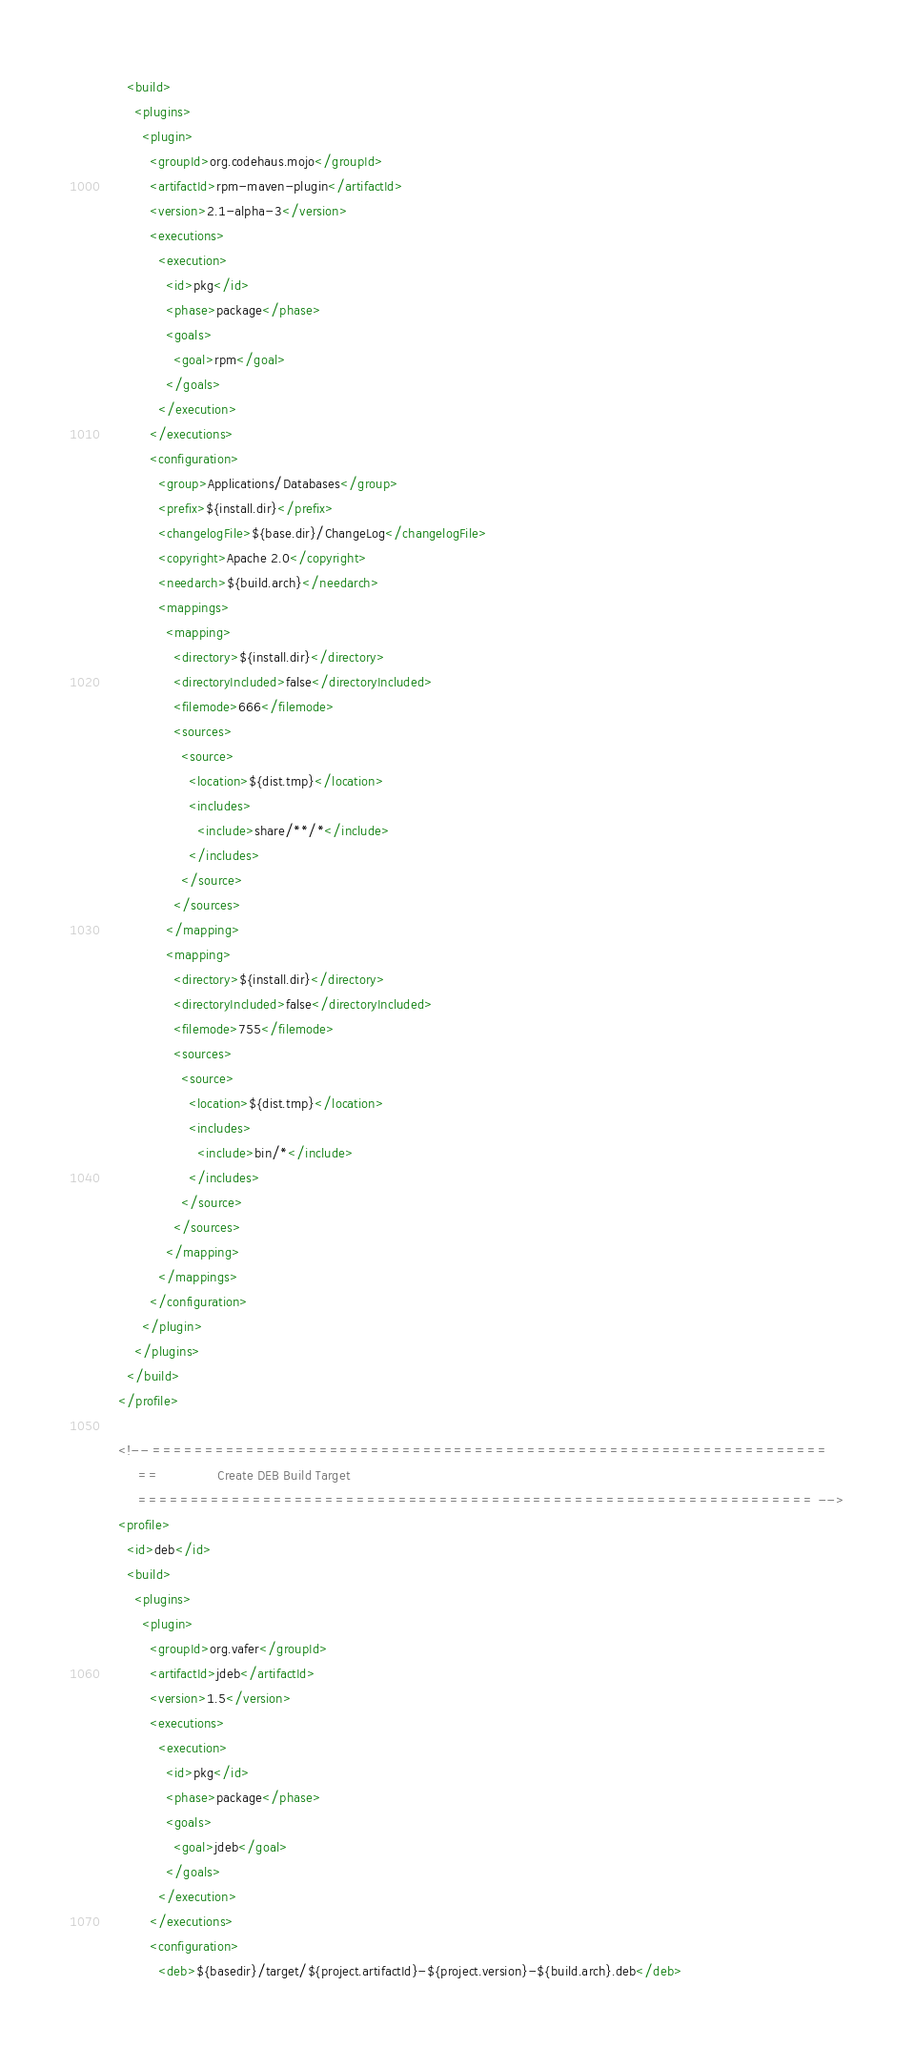<code> <loc_0><loc_0><loc_500><loc_500><_XML_>      <build>
        <plugins>
          <plugin>
            <groupId>org.codehaus.mojo</groupId>
            <artifactId>rpm-maven-plugin</artifactId>
            <version>2.1-alpha-3</version>
            <executions>
              <execution>
                <id>pkg</id>
                <phase>package</phase>
                <goals>
                  <goal>rpm</goal>
                </goals>
              </execution>
            </executions>
            <configuration>
              <group>Applications/Databases</group>
              <prefix>${install.dir}</prefix>
              <changelogFile>${base.dir}/ChangeLog</changelogFile>
              <copyright>Apache 2.0</copyright>
              <needarch>${build.arch}</needarch>
              <mappings>
                <mapping>
                  <directory>${install.dir}</directory>
                  <directoryIncluded>false</directoryIncluded>
                  <filemode>666</filemode>
                  <sources>
                    <source>
                      <location>${dist.tmp}</location>
                      <includes>
                        <include>share/**/*</include>
                      </includes>
                    </source>
                  </sources>
                </mapping>
                <mapping>
                  <directory>${install.dir}</directory>
                  <directoryIncluded>false</directoryIncluded>
                  <filemode>755</filemode>
                  <sources>
                    <source>
                      <location>${dist.tmp}</location>
                      <includes>
                        <include>bin/*</include>
                      </includes>
                    </source>
                  </sources>
                </mapping>
              </mappings>
            </configuration>
          </plugin>
        </plugins>
      </build>
    </profile>

    <!-- =================================================================
         ==               Create DEB Build Target
         ================================================================= -->
    <profile>
      <id>deb</id>
      <build>
        <plugins>
          <plugin>
            <groupId>org.vafer</groupId>
            <artifactId>jdeb</artifactId>
            <version>1.5</version>
            <executions>
              <execution>
                <id>pkg</id>
                <phase>package</phase>
                <goals>
                  <goal>jdeb</goal>
                </goals>
              </execution>
            </executions>
            <configuration>
              <deb>${basedir}/target/${project.artifactId}-${project.version}-${build.arch}.deb</deb></code> 